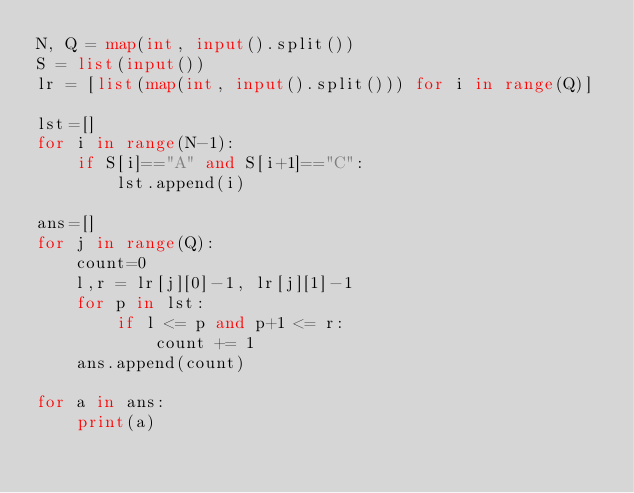Convert code to text. <code><loc_0><loc_0><loc_500><loc_500><_Python_>N, Q = map(int, input().split())
S = list(input())
lr = [list(map(int, input().split())) for i in range(Q)]

lst=[]
for i in range(N-1):
    if S[i]=="A" and S[i+1]=="C":
        lst.append(i)

ans=[]
for j in range(Q):
    count=0
    l,r = lr[j][0]-1, lr[j][1]-1
    for p in lst:
        if l <= p and p+1 <= r:
            count += 1
    ans.append(count)

for a in ans:
    print(a)
</code> 